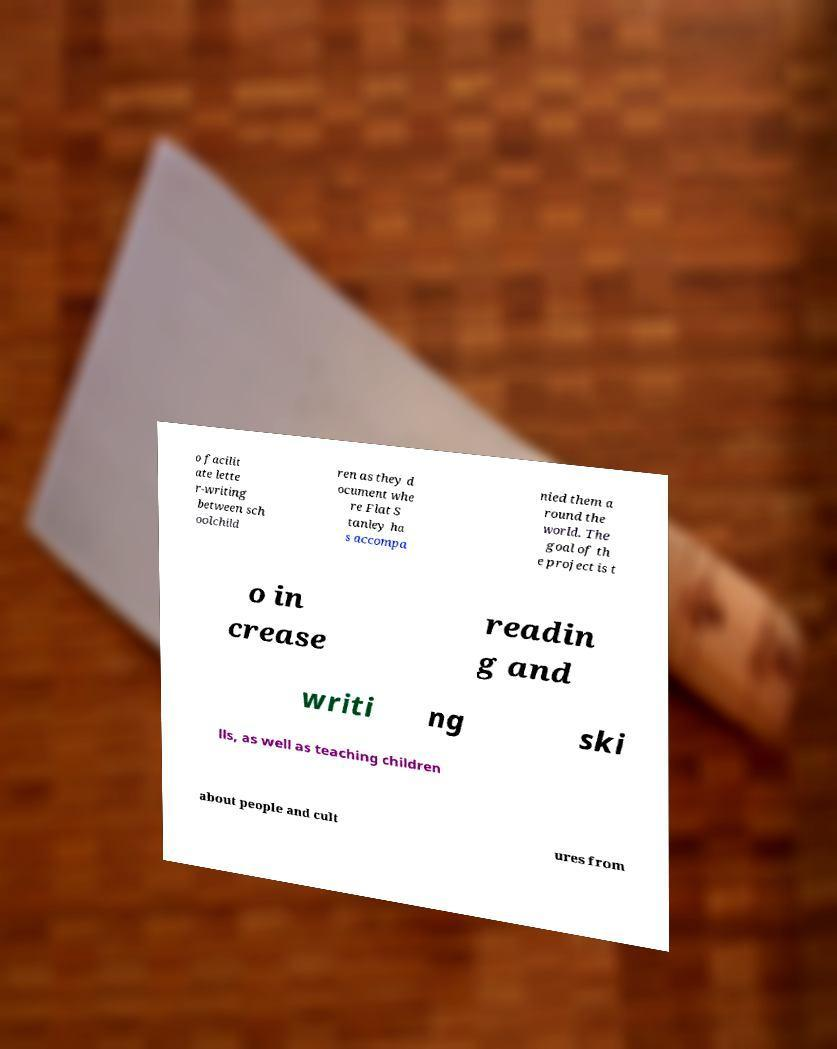Could you extract and type out the text from this image? o facilit ate lette r-writing between sch oolchild ren as they d ocument whe re Flat S tanley ha s accompa nied them a round the world. The goal of th e project is t o in crease readin g and writi ng ski lls, as well as teaching children about people and cult ures from 